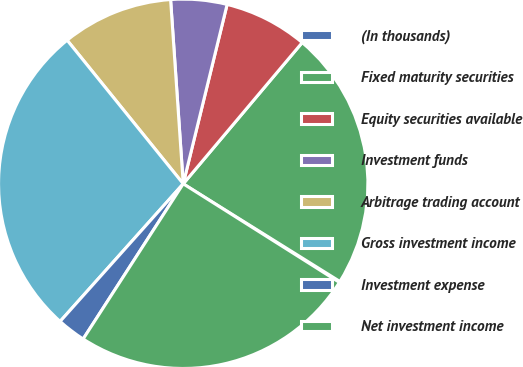Convert chart to OTSL. <chart><loc_0><loc_0><loc_500><loc_500><pie_chart><fcel>(In thousands)<fcel>Fixed maturity securities<fcel>Equity securities available<fcel>Investment funds<fcel>Arbitrage trading account<fcel>Gross investment income<fcel>Investment expense<fcel>Net investment income<nl><fcel>0.09%<fcel>22.73%<fcel>7.32%<fcel>4.91%<fcel>9.73%<fcel>27.56%<fcel>2.5%<fcel>25.15%<nl></chart> 